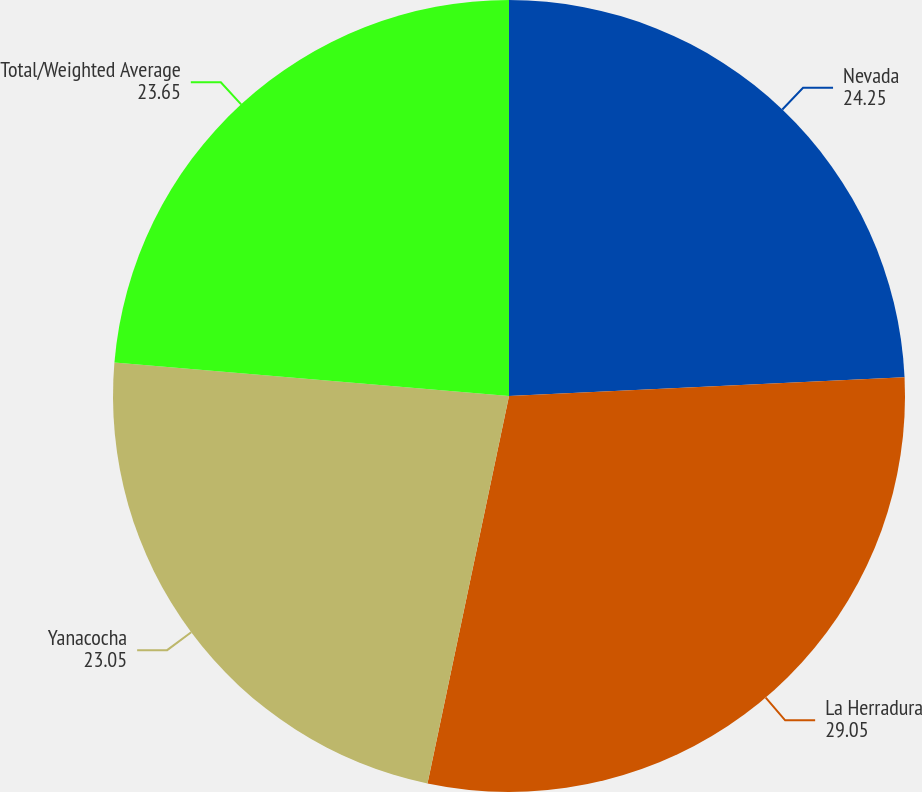Convert chart to OTSL. <chart><loc_0><loc_0><loc_500><loc_500><pie_chart><fcel>Nevada<fcel>La Herradura<fcel>Yanacocha<fcel>Total/Weighted Average<nl><fcel>24.25%<fcel>29.05%<fcel>23.05%<fcel>23.65%<nl></chart> 